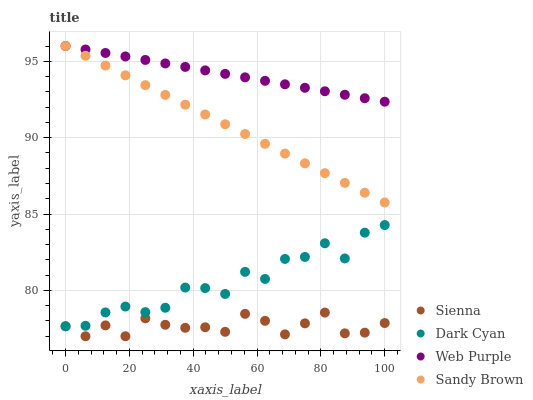Does Sienna have the minimum area under the curve?
Answer yes or no. Yes. Does Web Purple have the maximum area under the curve?
Answer yes or no. Yes. Does Dark Cyan have the minimum area under the curve?
Answer yes or no. No. Does Dark Cyan have the maximum area under the curve?
Answer yes or no. No. Is Sandy Brown the smoothest?
Answer yes or no. Yes. Is Dark Cyan the roughest?
Answer yes or no. Yes. Is Web Purple the smoothest?
Answer yes or no. No. Is Web Purple the roughest?
Answer yes or no. No. Does Sienna have the lowest value?
Answer yes or no. Yes. Does Dark Cyan have the lowest value?
Answer yes or no. No. Does Sandy Brown have the highest value?
Answer yes or no. Yes. Does Dark Cyan have the highest value?
Answer yes or no. No. Is Sienna less than Sandy Brown?
Answer yes or no. Yes. Is Sandy Brown greater than Sienna?
Answer yes or no. Yes. Does Web Purple intersect Sandy Brown?
Answer yes or no. Yes. Is Web Purple less than Sandy Brown?
Answer yes or no. No. Is Web Purple greater than Sandy Brown?
Answer yes or no. No. Does Sienna intersect Sandy Brown?
Answer yes or no. No. 